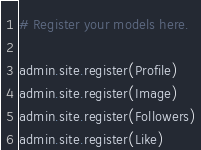<code> <loc_0><loc_0><loc_500><loc_500><_Python_># Register your models here.

admin.site.register(Profile)
admin.site.register(Image)
admin.site.register(Followers)
admin.site.register(Like)

</code> 